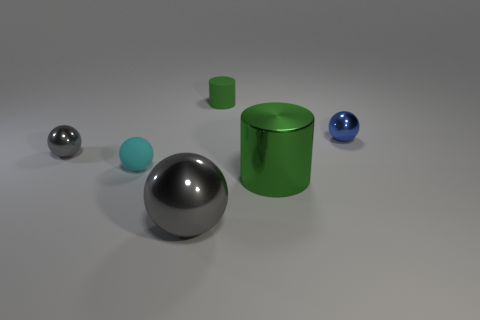Add 3 tiny metal cubes. How many objects exist? 9 Subtract all balls. How many objects are left? 2 Add 6 cyan cubes. How many cyan cubes exist? 6 Subtract 0 green spheres. How many objects are left? 6 Subtract all big brown matte balls. Subtract all tiny rubber spheres. How many objects are left? 5 Add 4 small metallic balls. How many small metallic balls are left? 6 